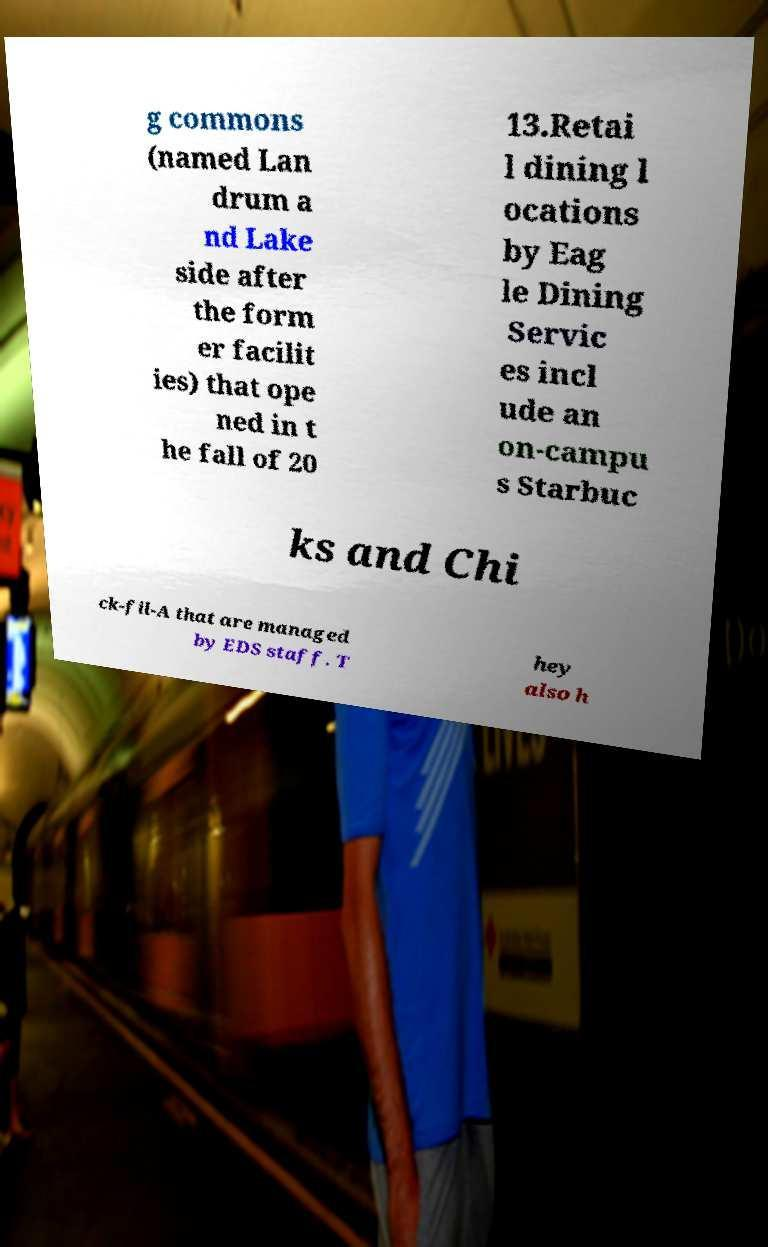Could you assist in decoding the text presented in this image and type it out clearly? g commons (named Lan drum a nd Lake side after the form er facilit ies) that ope ned in t he fall of 20 13.Retai l dining l ocations by Eag le Dining Servic es incl ude an on-campu s Starbuc ks and Chi ck-fil-A that are managed by EDS staff. T hey also h 